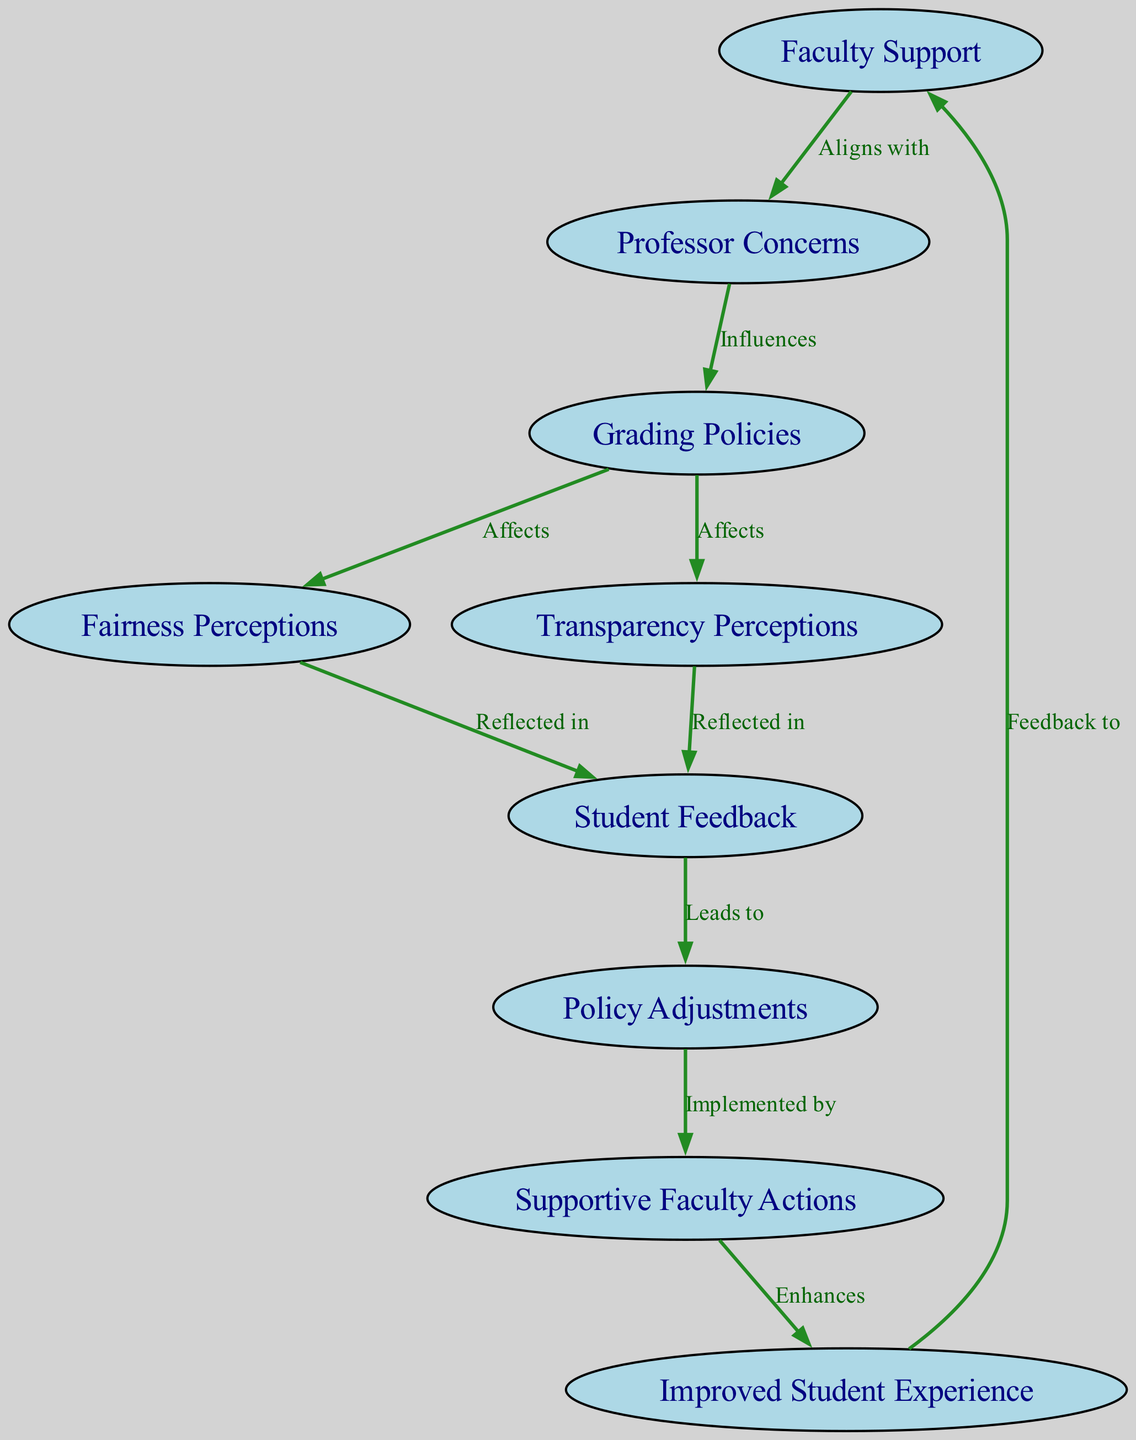What node is influenced by professor concerns? The edge from "Professor Concerns" points to "Grading Policies", indicating that grading policies are influenced by professor concerns.
Answer: Grading Policies How many nodes are in the diagram? The diagram contains a total of 9 nodes representing different concepts related to faculty and student perceptions.
Answer: 9 What does faculty support align with? The edge from "Faculty Support" to "Professor Concerns" shows that faculty support aligns with concerns expressed by professors.
Answer: Professor Concerns What leads to policy adjustments? Student feedback leads to policy adjustments, as indicated by the edge connecting "Student Feedback" to "Policy Adjustments".
Answer: Student Feedback Which node enhances the improved student experience? The edge from "Supportive Faculty Actions" to "Improved Student Experience" indicates that supportive faculty actions enhance the student experience.
Answer: Supportive Faculty Actions How many edges are there in total? The diagram consists of 9 edges, detailing the relationships between the various nodes.
Answer: 9 What do fairness perceptions reflect in the diagram? Fairness perceptions are reflected in student feedback, as seen by the edge connecting "Fairness Perceptions" to "Student Feedback".
Answer: Student Feedback What does transparency perceptions reflect in student feedback? The edge from "Transparency Perceptions" to "Student Feedback" illustrates that transparency perceptions are also reflected in student feedback.
Answer: Student Feedback What is the relationship between grading policies and fairness perceptions? The edge from "Grading Policies" to "Fairness Perceptions" shows that grading policies affect fairness perceptions.
Answer: Affects 